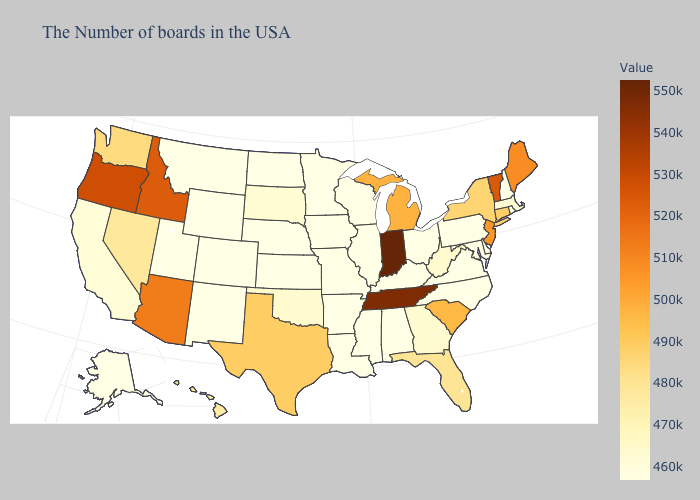Which states have the lowest value in the USA?
Be succinct. Rhode Island, New Hampshire, Delaware, Maryland, Pennsylvania, Virginia, North Carolina, Ohio, Kentucky, Alabama, Wisconsin, Illinois, Mississippi, Louisiana, Missouri, Arkansas, Minnesota, Iowa, Kansas, Nebraska, North Dakota, Wyoming, Colorado, New Mexico, Utah, Montana, Alaska. Among the states that border Alabama , which have the lowest value?
Short answer required. Mississippi. Among the states that border Kansas , which have the lowest value?
Short answer required. Missouri, Nebraska, Colorado. Does the map have missing data?
Answer briefly. No. Among the states that border Iowa , does Minnesota have the highest value?
Short answer required. No. 